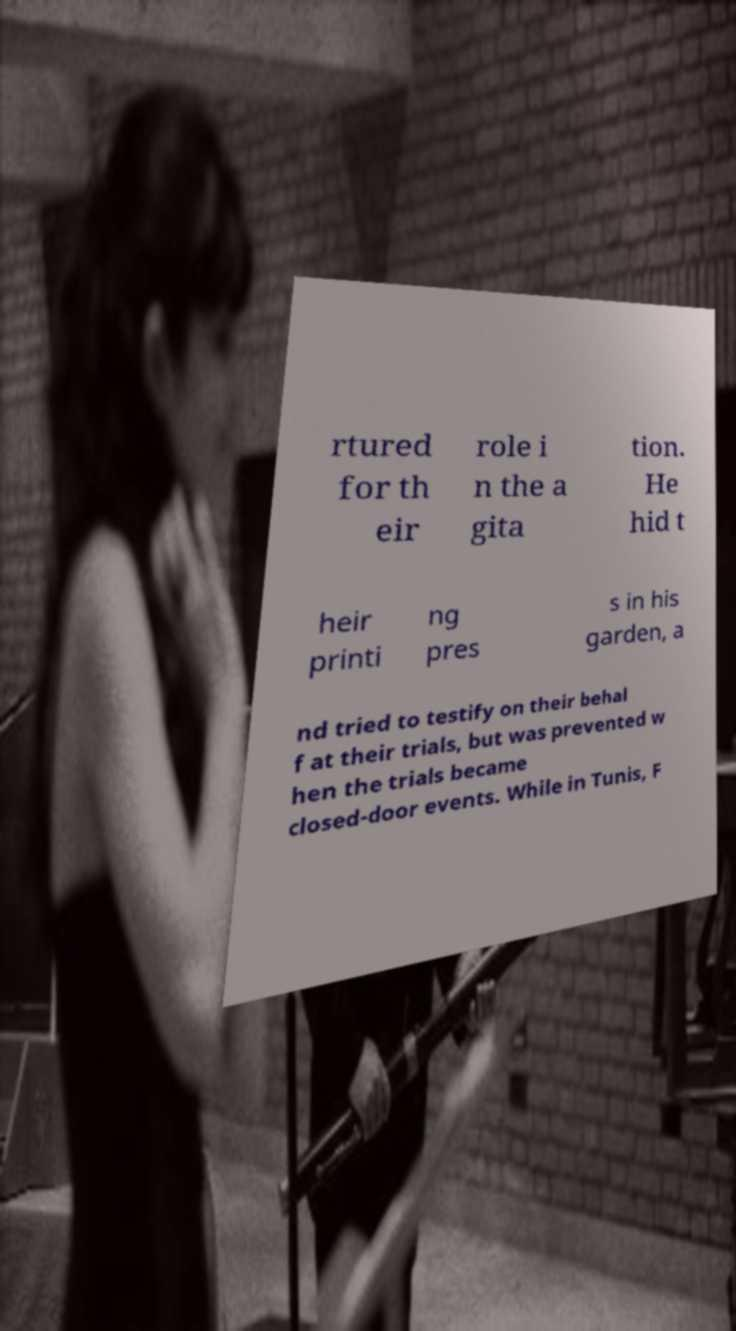There's text embedded in this image that I need extracted. Can you transcribe it verbatim? rtured for th eir role i n the a gita tion. He hid t heir printi ng pres s in his garden, a nd tried to testify on their behal f at their trials, but was prevented w hen the trials became closed-door events. While in Tunis, F 